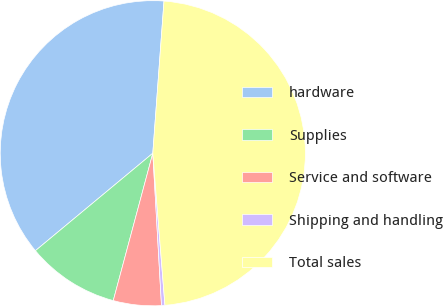Convert chart to OTSL. <chart><loc_0><loc_0><loc_500><loc_500><pie_chart><fcel>hardware<fcel>Supplies<fcel>Service and software<fcel>Shipping and handling<fcel>Total sales<nl><fcel>37.2%<fcel>9.8%<fcel>5.08%<fcel>0.36%<fcel>47.57%<nl></chart> 